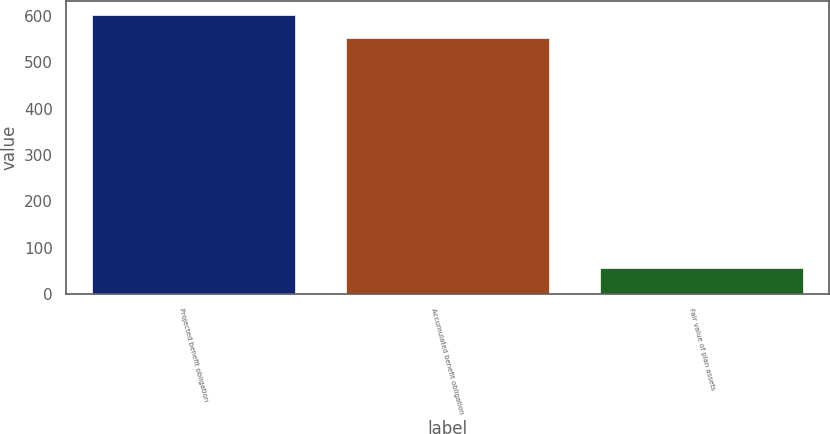<chart> <loc_0><loc_0><loc_500><loc_500><bar_chart><fcel>Projected benefit obligation<fcel>Accumulated benefit obligation<fcel>Fair value of plan assets<nl><fcel>603<fcel>552<fcel>56<nl></chart> 